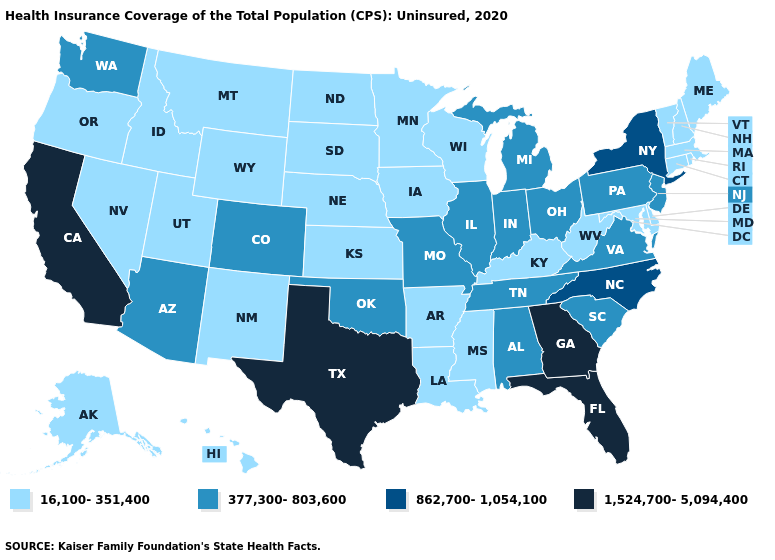Does Indiana have the highest value in the USA?
Quick response, please. No. Name the states that have a value in the range 377,300-803,600?
Be succinct. Alabama, Arizona, Colorado, Illinois, Indiana, Michigan, Missouri, New Jersey, Ohio, Oklahoma, Pennsylvania, South Carolina, Tennessee, Virginia, Washington. Does the first symbol in the legend represent the smallest category?
Write a very short answer. Yes. Does New Hampshire have a lower value than Tennessee?
Answer briefly. Yes. Does Missouri have the highest value in the MidWest?
Keep it brief. Yes. Does Georgia have the highest value in the USA?
Short answer required. Yes. Name the states that have a value in the range 16,100-351,400?
Concise answer only. Alaska, Arkansas, Connecticut, Delaware, Hawaii, Idaho, Iowa, Kansas, Kentucky, Louisiana, Maine, Maryland, Massachusetts, Minnesota, Mississippi, Montana, Nebraska, Nevada, New Hampshire, New Mexico, North Dakota, Oregon, Rhode Island, South Dakota, Utah, Vermont, West Virginia, Wisconsin, Wyoming. What is the value of Arkansas?
Short answer required. 16,100-351,400. Does the first symbol in the legend represent the smallest category?
Give a very brief answer. Yes. Does Connecticut have the highest value in the USA?
Answer briefly. No. What is the value of North Dakota?
Short answer required. 16,100-351,400. What is the value of Oregon?
Be succinct. 16,100-351,400. Does the map have missing data?
Be succinct. No. What is the value of Missouri?
Answer briefly. 377,300-803,600. Name the states that have a value in the range 1,524,700-5,094,400?
Concise answer only. California, Florida, Georgia, Texas. 